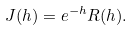Convert formula to latex. <formula><loc_0><loc_0><loc_500><loc_500>J ( h ) = e ^ { - h } R ( h ) .</formula> 